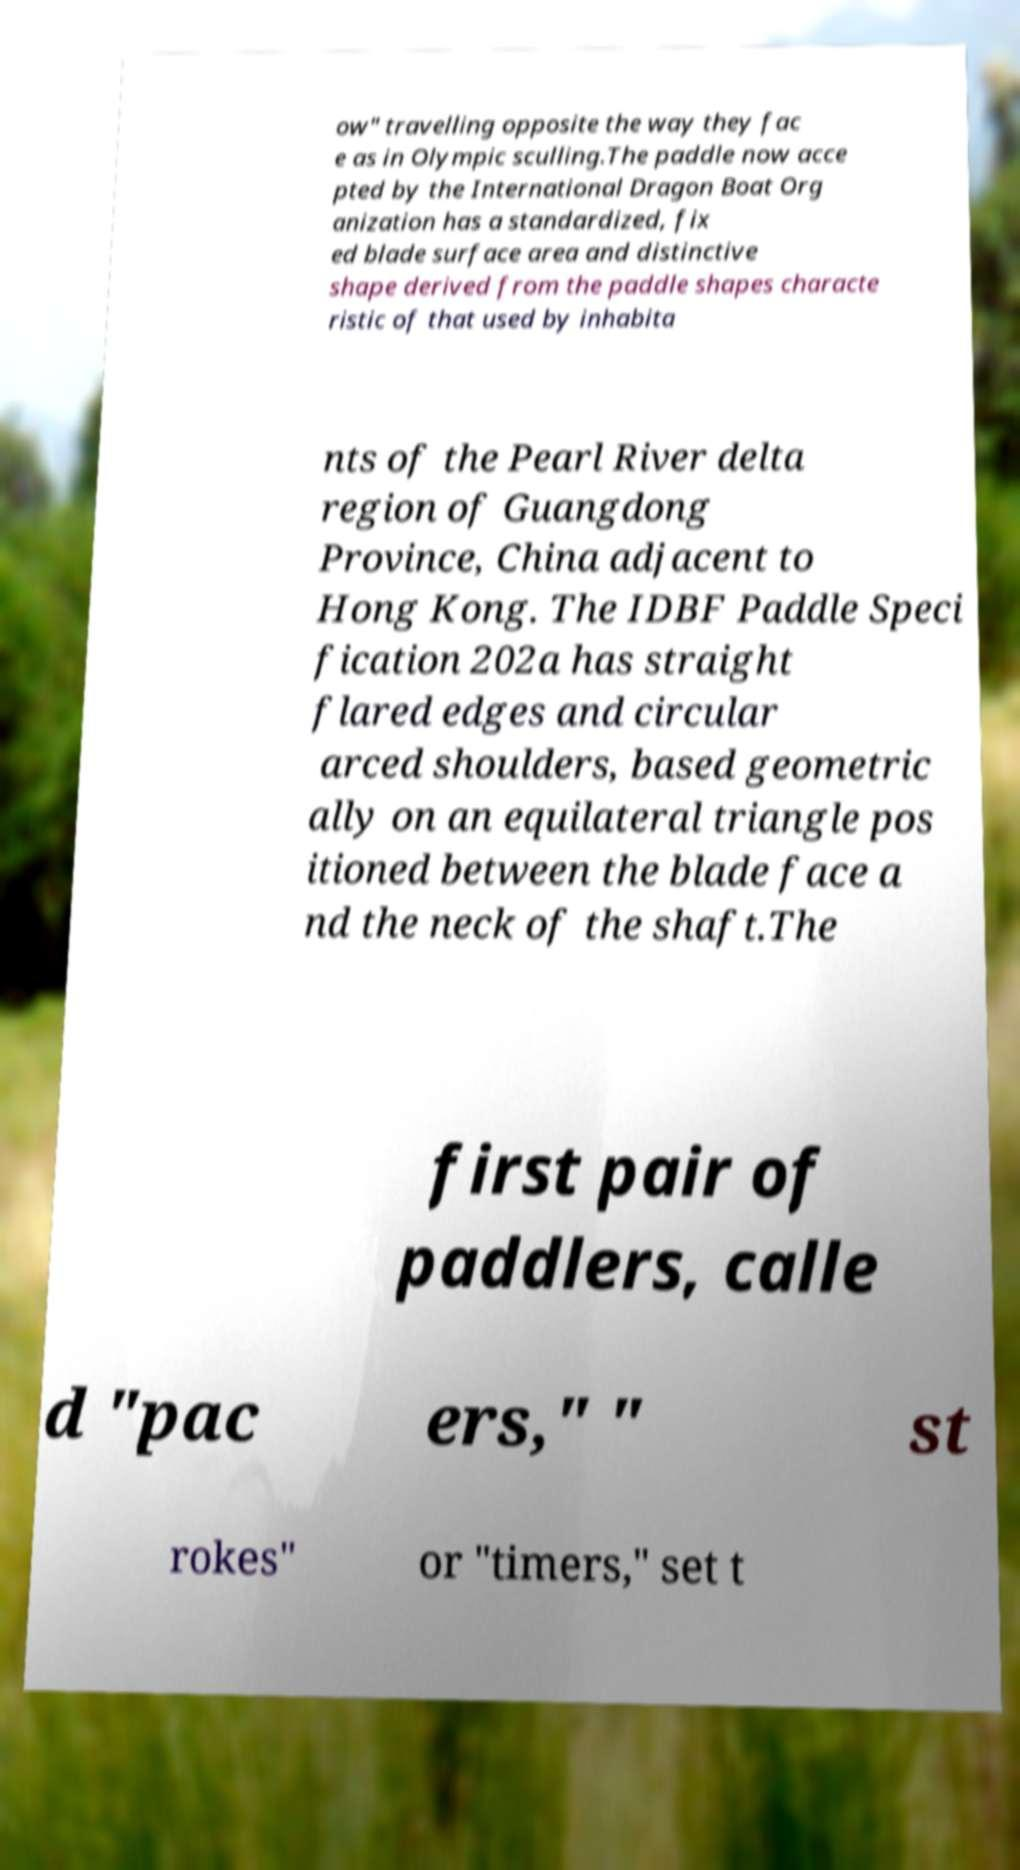Could you assist in decoding the text presented in this image and type it out clearly? ow" travelling opposite the way they fac e as in Olympic sculling.The paddle now acce pted by the International Dragon Boat Org anization has a standardized, fix ed blade surface area and distinctive shape derived from the paddle shapes characte ristic of that used by inhabita nts of the Pearl River delta region of Guangdong Province, China adjacent to Hong Kong. The IDBF Paddle Speci fication 202a has straight flared edges and circular arced shoulders, based geometric ally on an equilateral triangle pos itioned between the blade face a nd the neck of the shaft.The first pair of paddlers, calle d "pac ers," " st rokes" or "timers," set t 